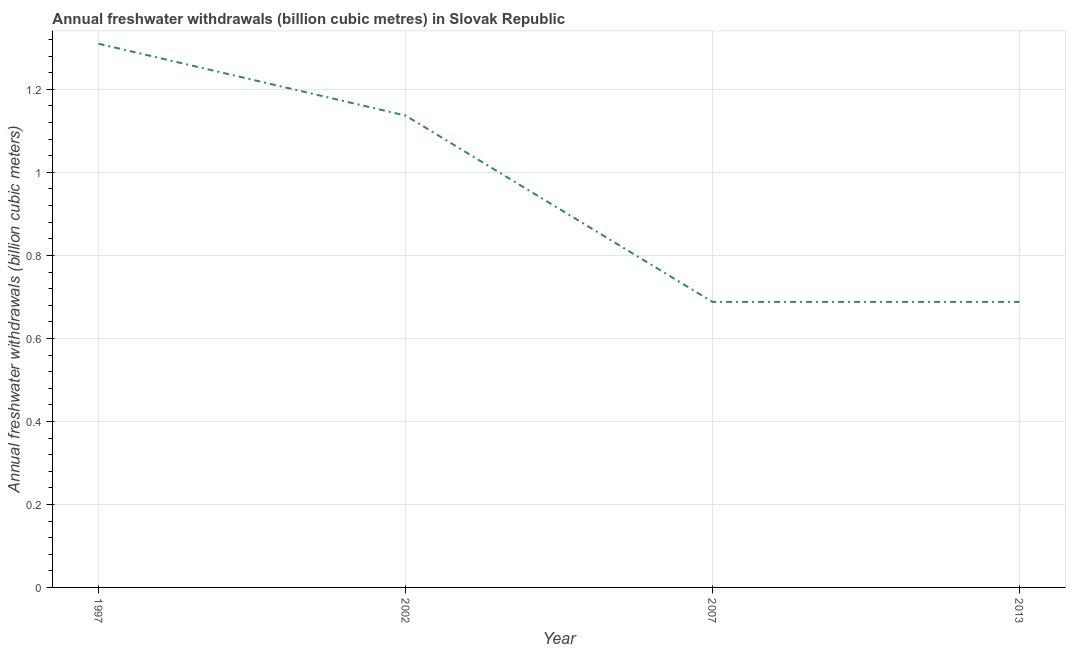What is the annual freshwater withdrawals in 1997?
Offer a terse response. 1.31. Across all years, what is the maximum annual freshwater withdrawals?
Your response must be concise. 1.31. Across all years, what is the minimum annual freshwater withdrawals?
Give a very brief answer. 0.69. In which year was the annual freshwater withdrawals maximum?
Ensure brevity in your answer.  1997. What is the sum of the annual freshwater withdrawals?
Offer a terse response. 3.82. What is the difference between the annual freshwater withdrawals in 1997 and 2013?
Offer a terse response. 0.62. What is the average annual freshwater withdrawals per year?
Your answer should be compact. 0.96. What is the median annual freshwater withdrawals?
Make the answer very short. 0.91. What is the ratio of the annual freshwater withdrawals in 2002 to that in 2007?
Offer a terse response. 1.65. Is the annual freshwater withdrawals in 2002 less than that in 2013?
Ensure brevity in your answer.  No. Is the difference between the annual freshwater withdrawals in 2007 and 2013 greater than the difference between any two years?
Ensure brevity in your answer.  No. What is the difference between the highest and the second highest annual freshwater withdrawals?
Offer a very short reply. 0.17. Is the sum of the annual freshwater withdrawals in 2002 and 2007 greater than the maximum annual freshwater withdrawals across all years?
Provide a short and direct response. Yes. What is the difference between the highest and the lowest annual freshwater withdrawals?
Your response must be concise. 0.62. Does the annual freshwater withdrawals monotonically increase over the years?
Provide a succinct answer. No. How many lines are there?
Offer a terse response. 1. How many years are there in the graph?
Keep it short and to the point. 4. What is the difference between two consecutive major ticks on the Y-axis?
Offer a very short reply. 0.2. Are the values on the major ticks of Y-axis written in scientific E-notation?
Provide a short and direct response. No. Does the graph contain grids?
Your response must be concise. Yes. What is the title of the graph?
Your answer should be compact. Annual freshwater withdrawals (billion cubic metres) in Slovak Republic. What is the label or title of the X-axis?
Provide a succinct answer. Year. What is the label or title of the Y-axis?
Provide a short and direct response. Annual freshwater withdrawals (billion cubic meters). What is the Annual freshwater withdrawals (billion cubic meters) of 1997?
Make the answer very short. 1.31. What is the Annual freshwater withdrawals (billion cubic meters) in 2002?
Provide a short and direct response. 1.14. What is the Annual freshwater withdrawals (billion cubic meters) of 2007?
Provide a succinct answer. 0.69. What is the Annual freshwater withdrawals (billion cubic meters) of 2013?
Offer a very short reply. 0.69. What is the difference between the Annual freshwater withdrawals (billion cubic meters) in 1997 and 2002?
Keep it short and to the point. 0.17. What is the difference between the Annual freshwater withdrawals (billion cubic meters) in 1997 and 2007?
Your answer should be compact. 0.62. What is the difference between the Annual freshwater withdrawals (billion cubic meters) in 1997 and 2013?
Provide a succinct answer. 0.62. What is the difference between the Annual freshwater withdrawals (billion cubic meters) in 2002 and 2007?
Give a very brief answer. 0.45. What is the difference between the Annual freshwater withdrawals (billion cubic meters) in 2002 and 2013?
Keep it short and to the point. 0.45. What is the ratio of the Annual freshwater withdrawals (billion cubic meters) in 1997 to that in 2002?
Your answer should be very brief. 1.15. What is the ratio of the Annual freshwater withdrawals (billion cubic meters) in 1997 to that in 2007?
Your response must be concise. 1.9. What is the ratio of the Annual freshwater withdrawals (billion cubic meters) in 1997 to that in 2013?
Your answer should be compact. 1.9. What is the ratio of the Annual freshwater withdrawals (billion cubic meters) in 2002 to that in 2007?
Provide a succinct answer. 1.65. What is the ratio of the Annual freshwater withdrawals (billion cubic meters) in 2002 to that in 2013?
Your response must be concise. 1.65. What is the ratio of the Annual freshwater withdrawals (billion cubic meters) in 2007 to that in 2013?
Make the answer very short. 1. 